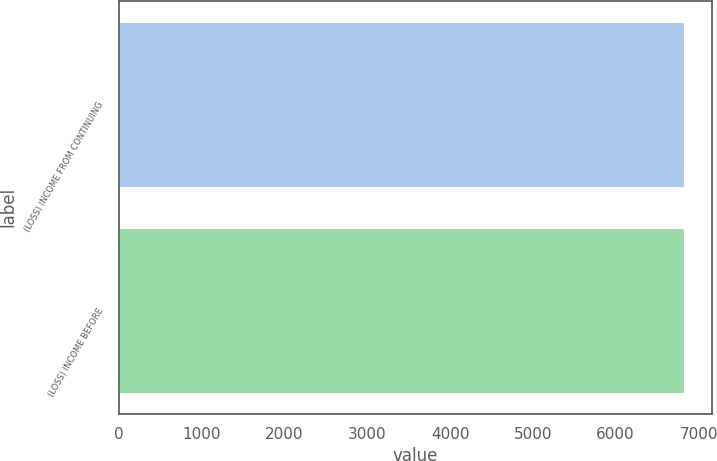Convert chart. <chart><loc_0><loc_0><loc_500><loc_500><bar_chart><fcel>(LOSS) INCOME FROM CONTINUING<fcel>(LOSS) INCOME BEFORE<nl><fcel>6825<fcel>6825.1<nl></chart> 